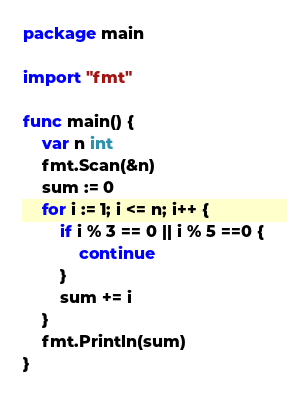Convert code to text. <code><loc_0><loc_0><loc_500><loc_500><_Go_>package main

import "fmt"

func main() {
	var n int
	fmt.Scan(&n)
	sum := 0
	for i := 1; i <= n; i++ {
		if i % 3 == 0 || i % 5 ==0 {
			continue
		}
		sum += i
	}
	fmt.Println(sum)
}</code> 